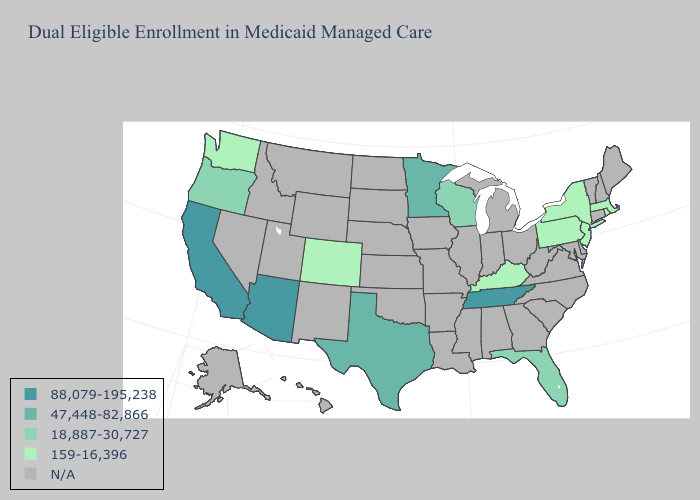Does the first symbol in the legend represent the smallest category?
Concise answer only. No. Name the states that have a value in the range 47,448-82,866?
Concise answer only. Minnesota, Texas. Name the states that have a value in the range 47,448-82,866?
Quick response, please. Minnesota, Texas. Does the first symbol in the legend represent the smallest category?
Answer briefly. No. What is the value of New York?
Quick response, please. 159-16,396. What is the value of New Mexico?
Answer briefly. N/A. What is the lowest value in states that border Maryland?
Concise answer only. 159-16,396. Does Washington have the highest value in the West?
Quick response, please. No. Which states have the lowest value in the South?
Quick response, please. Kentucky. What is the lowest value in the USA?
Be succinct. 159-16,396. Name the states that have a value in the range N/A?
Keep it brief. Alabama, Alaska, Arkansas, Connecticut, Delaware, Georgia, Hawaii, Idaho, Illinois, Indiana, Iowa, Kansas, Louisiana, Maine, Maryland, Michigan, Mississippi, Missouri, Montana, Nebraska, Nevada, New Hampshire, New Mexico, North Carolina, North Dakota, Ohio, Oklahoma, South Carolina, South Dakota, Utah, Vermont, Virginia, West Virginia, Wyoming. What is the highest value in the South ?
Be succinct. 88,079-195,238. What is the value of Connecticut?
Short answer required. N/A. 